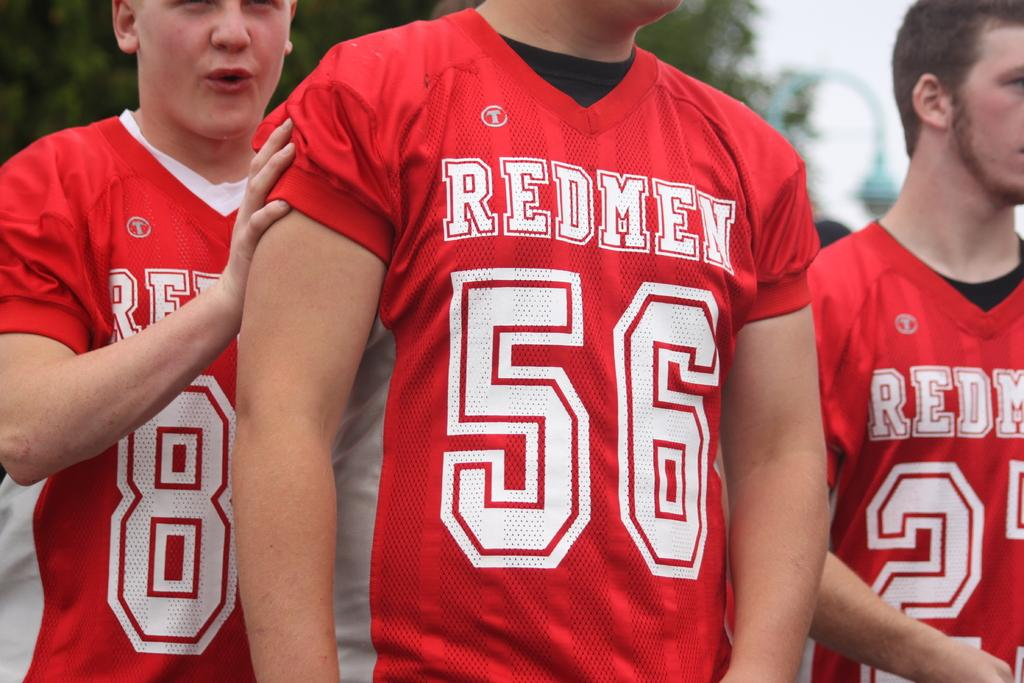Provide a one-sentence caption for the provided image. A close up of three young boys wearing Redmen football jerseys. 